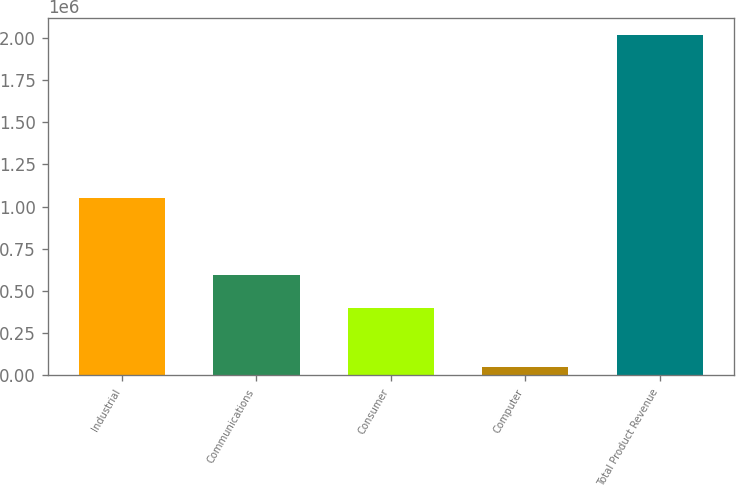<chart> <loc_0><loc_0><loc_500><loc_500><bar_chart><fcel>Industrial<fcel>Communications<fcel>Consumer<fcel>Computer<fcel>Total Product Revenue<nl><fcel>1.04916e+06<fcel>596529<fcel>400290<fcel>52519<fcel>2.01491e+06<nl></chart> 